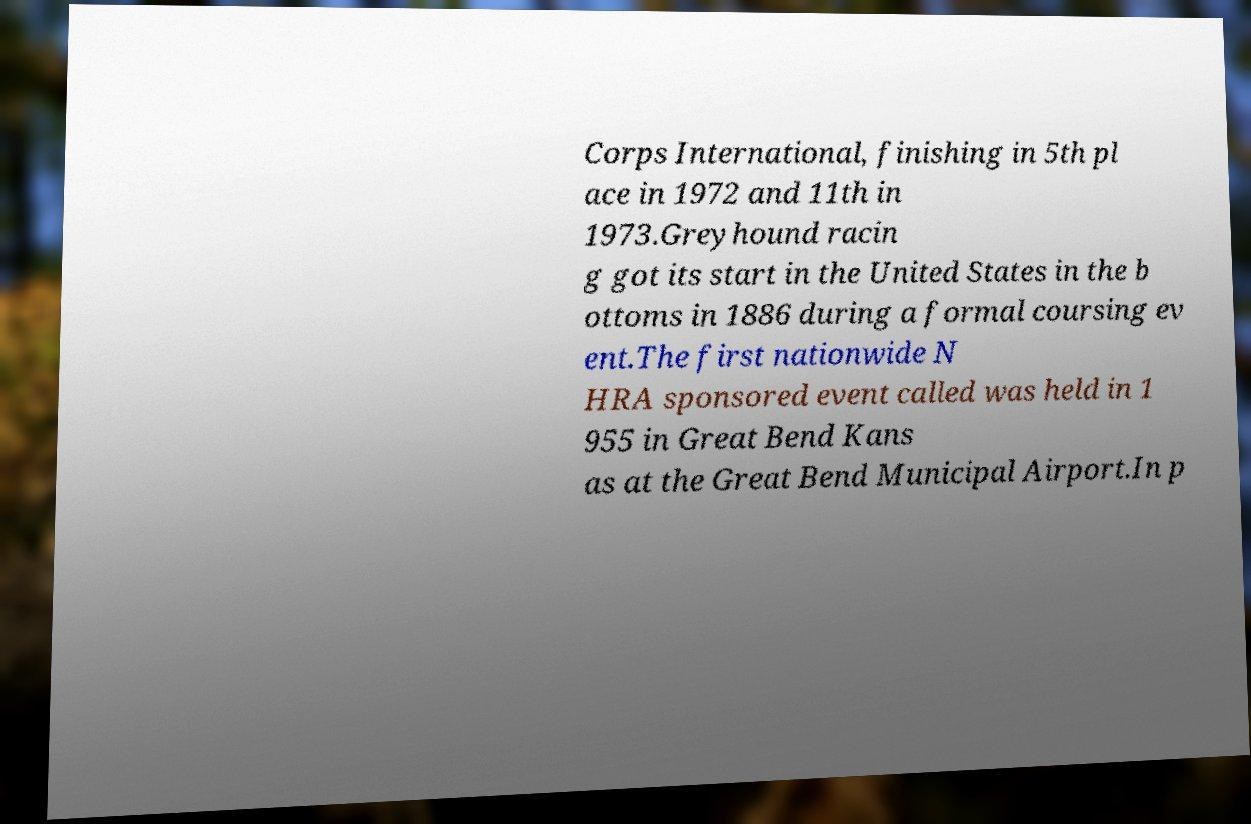Could you assist in decoding the text presented in this image and type it out clearly? Corps International, finishing in 5th pl ace in 1972 and 11th in 1973.Greyhound racin g got its start in the United States in the b ottoms in 1886 during a formal coursing ev ent.The first nationwide N HRA sponsored event called was held in 1 955 in Great Bend Kans as at the Great Bend Municipal Airport.In p 